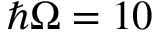Convert formula to latex. <formula><loc_0><loc_0><loc_500><loc_500>\hbar { \Omega } = 1 0</formula> 